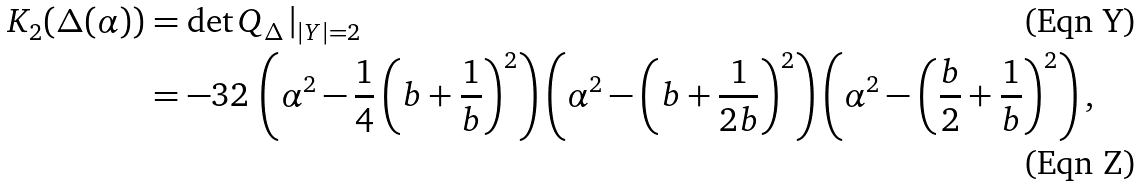Convert formula to latex. <formula><loc_0><loc_0><loc_500><loc_500>K _ { 2 } ( \Delta ( \alpha ) ) & = \det Q _ { \Delta } \, | _ { | Y | = 2 } \\ & = - 3 2 \, \left ( \alpha ^ { 2 } - \frac { 1 } { 4 } \left ( b + \frac { 1 } { b } \right ) ^ { 2 } \right ) \left ( \alpha ^ { 2 } - \left ( b + \frac { 1 } { 2 b } \right ) ^ { 2 } \right ) \left ( \alpha ^ { 2 } - \left ( \frac { b } { 2 } + \frac { 1 } { b } \right ) ^ { 2 } \right ) ,</formula> 